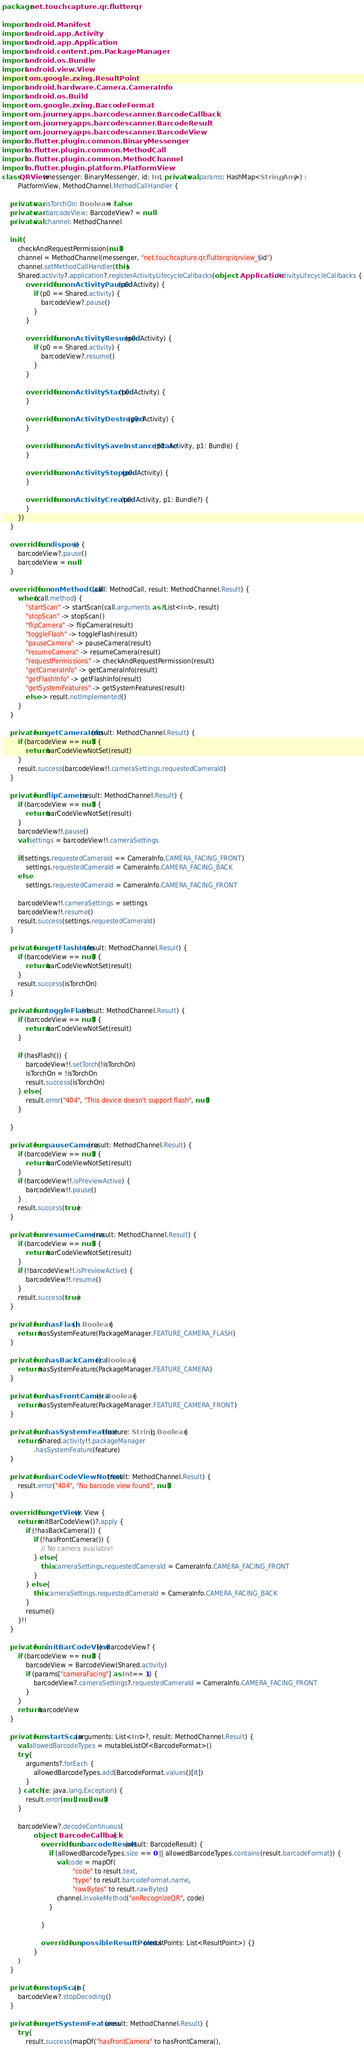Convert code to text. <code><loc_0><loc_0><loc_500><loc_500><_Kotlin_>package net.touchcapture.qr.flutterqr

import android.Manifest
import android.app.Activity
import android.app.Application
import android.content.pm.PackageManager
import android.os.Bundle
import android.view.View
import com.google.zxing.ResultPoint
import android.hardware.Camera.CameraInfo
import android.os.Build
import com.google.zxing.BarcodeFormat
import com.journeyapps.barcodescanner.BarcodeCallback
import com.journeyapps.barcodescanner.BarcodeResult
import com.journeyapps.barcodescanner.BarcodeView
import io.flutter.plugin.common.BinaryMessenger
import io.flutter.plugin.common.MethodCall
import io.flutter.plugin.common.MethodChannel
import io.flutter.plugin.platform.PlatformView
class QRView(messenger: BinaryMessenger, id: Int, private val params: HashMap<String, Any>) :
        PlatformView, MethodChannel.MethodCallHandler {

    private var isTorchOn: Boolean = false
    private var barcodeView: BarcodeView? = null
    private val channel: MethodChannel

    init {
        checkAndRequestPermission(null)
        channel = MethodChannel(messenger, "net.touchcapture.qr.flutterqr/qrview_$id")
        channel.setMethodCallHandler(this)
        Shared.activity?.application?.registerActivityLifecycleCallbacks(object : Application.ActivityLifecycleCallbacks {
            override fun onActivityPaused(p0: Activity) {
                if (p0 == Shared.activity) {
                    barcodeView?.pause()
                }
            }

            override fun onActivityResumed(p0: Activity) {
                if (p0 == Shared.activity) {
                    barcodeView?.resume()
                }
            }

            override fun onActivityStarted(p0: Activity) {
            }

            override fun onActivityDestroyed(p0: Activity) {
            }

            override fun onActivitySaveInstanceState(p0: Activity, p1: Bundle) {
            }

            override fun onActivityStopped(p0: Activity) {
            }

            override fun onActivityCreated(p0: Activity, p1: Bundle?) {
            }
        })
    }

    override fun dispose() {
        barcodeView?.pause()
        barcodeView = null
    }

    override fun onMethodCall(call: MethodCall, result: MethodChannel.Result) {
        when(call.method) {
            "startScan" -> startScan(call.arguments as? List<Int>, result)
            "stopScan" -> stopScan()
            "flipCamera" -> flipCamera(result)
            "toggleFlash" -> toggleFlash(result)
            "pauseCamera" -> pauseCamera(result)
            "resumeCamera" -> resumeCamera(result)
            "requestPermissions" -> checkAndRequestPermission(result)
            "getCameraInfo" -> getCameraInfo(result)
            "getFlashInfo" -> getFlashInfo(result)
            "getSystemFeatures" -> getSystemFeatures(result)
            else -> result.notImplemented()
        }
    }

    private fun getCameraInfo(result: MethodChannel.Result) {
        if (barcodeView == null) {
            return barCodeViewNotSet(result)
        }
        result.success(barcodeView!!.cameraSettings.requestedCameraId)
    }

    private fun flipCamera(result: MethodChannel.Result) {
        if (barcodeView == null) {
            return barCodeViewNotSet(result)
        }
        barcodeView!!.pause()
        val settings = barcodeView!!.cameraSettings

        if(settings.requestedCameraId == CameraInfo.CAMERA_FACING_FRONT)
            settings.requestedCameraId = CameraInfo.CAMERA_FACING_BACK
        else
            settings.requestedCameraId = CameraInfo.CAMERA_FACING_FRONT

        barcodeView!!.cameraSettings = settings
        barcodeView!!.resume()
        result.success(settings.requestedCameraId)
    }

    private fun getFlashInfo(result: MethodChannel.Result) {
        if (barcodeView == null) {
            return barCodeViewNotSet(result)
        }
        result.success(isTorchOn)
    }

    private fun toggleFlash(result: MethodChannel.Result) {
        if (barcodeView == null) {
            return barCodeViewNotSet(result)
        }

        if (hasFlash()) {
            barcodeView!!.setTorch(!isTorchOn)
            isTorchOn = !isTorchOn
            result.success(isTorchOn)
        } else {
            result.error("404", "This device doesn't support flash", null)
        }

    }

    private fun pauseCamera(result: MethodChannel.Result) {
        if (barcodeView == null) {
            return barCodeViewNotSet(result)
        }
        if (barcodeView!!.isPreviewActive) {
            barcodeView!!.pause()
        }
        result.success(true)
    }

    private fun resumeCamera(result: MethodChannel.Result) {
        if (barcodeView == null) {
            return barCodeViewNotSet(result)
        }
        if (!barcodeView!!.isPreviewActive) {
            barcodeView!!.resume()
        }
        result.success(true)
    }

    private fun hasFlash(): Boolean {
        return hasSystemFeature(PackageManager.FEATURE_CAMERA_FLASH)
    }

    private fun hasBackCamera(): Boolean {
        return hasSystemFeature(PackageManager.FEATURE_CAMERA)
    }

    private fun hasFrontCamera(): Boolean {
        return hasSystemFeature(PackageManager.FEATURE_CAMERA_FRONT)
    }

    private fun hasSystemFeature(feature: String): Boolean {
        return Shared.activity!!.packageManager
                .hasSystemFeature(feature)
    }

    private fun barCodeViewNotSet(result: MethodChannel.Result) {
        result.error("404", "No barcode view found", null)
    }

    override fun getView(): View {
        return initBarCodeView()?.apply {
            if (!hasBackCamera()) {
                if (!hasFrontCamera()) {
                    // No camera available!
                } else {
                    this.cameraSettings.requestedCameraId = CameraInfo.CAMERA_FACING_FRONT
                }
            } else {
                this.cameraSettings.requestedCameraId = CameraInfo.CAMERA_FACING_BACK
            }
            resume()
        }!!
    }

    private fun initBarCodeView(): BarcodeView? {
        if (barcodeView == null) {
            barcodeView = BarcodeView(Shared.activity)
            if (params["cameraFacing"] as Int == 1) {
                barcodeView?.cameraSettings?.requestedCameraId = CameraInfo.CAMERA_FACING_FRONT
            }
        }
        return barcodeView
    }

    private fun startScan(arguments: List<Int>?, result: MethodChannel.Result) {
        val allowedBarcodeTypes = mutableListOf<BarcodeFormat>()
        try {
            arguments?.forEach {
                allowedBarcodeTypes.add(BarcodeFormat.values()[it])
            }
        } catch (e: java.lang.Exception) {
            result.error(null, null, null)
        }

        barcodeView?.decodeContinuous(
                object : BarcodeCallback {
                    override fun barcodeResult(result: BarcodeResult) {
                        if (allowedBarcodeTypes.size == 0 || allowedBarcodeTypes.contains(result.barcodeFormat)) {
                            val code = mapOf(
                                    "code" to result.text,
                                    "type" to result.barcodeFormat.name,
                                    "rawBytes" to result.rawBytes)
                            channel.invokeMethod("onRecognizeQR", code)
                        }

                    }

                    override fun possibleResultPoints(resultPoints: List<ResultPoint>) {}
                }
        )
    }

    private fun stopScan() {
        barcodeView?.stopDecoding()
    }

    private fun getSystemFeatures(result: MethodChannel.Result) {
        try {
            result.success(mapOf("hasFrontCamera" to hasFrontCamera(),</code> 